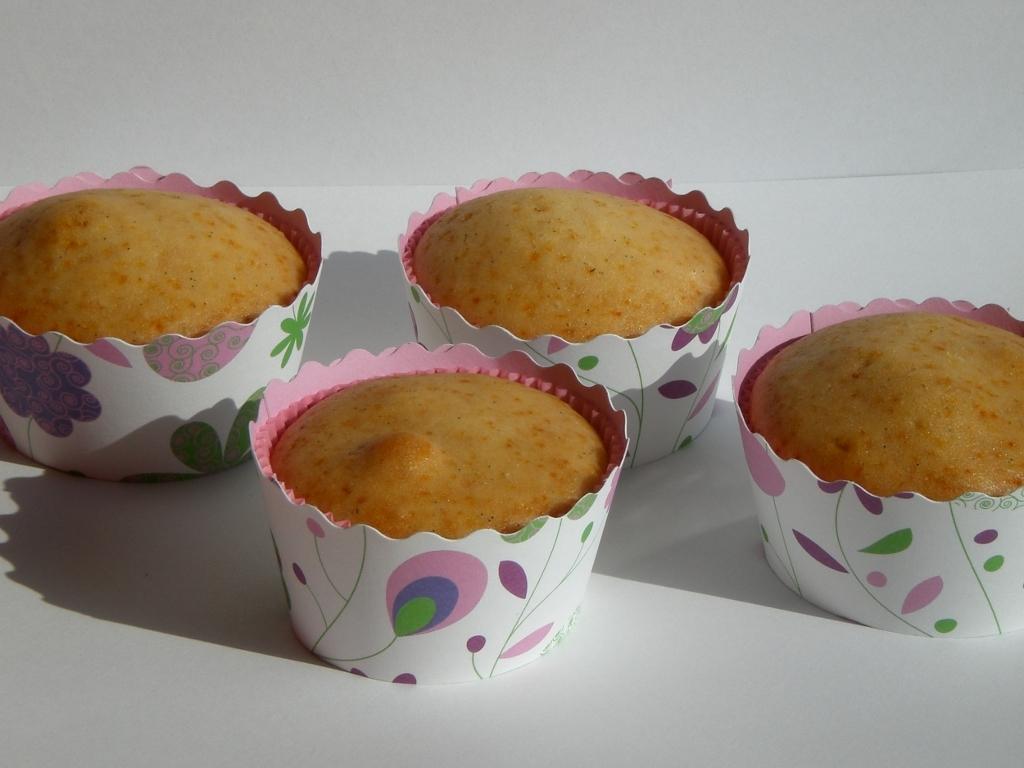In one or two sentences, can you explain what this image depicts? In this image there are four cupcakes on the table. 